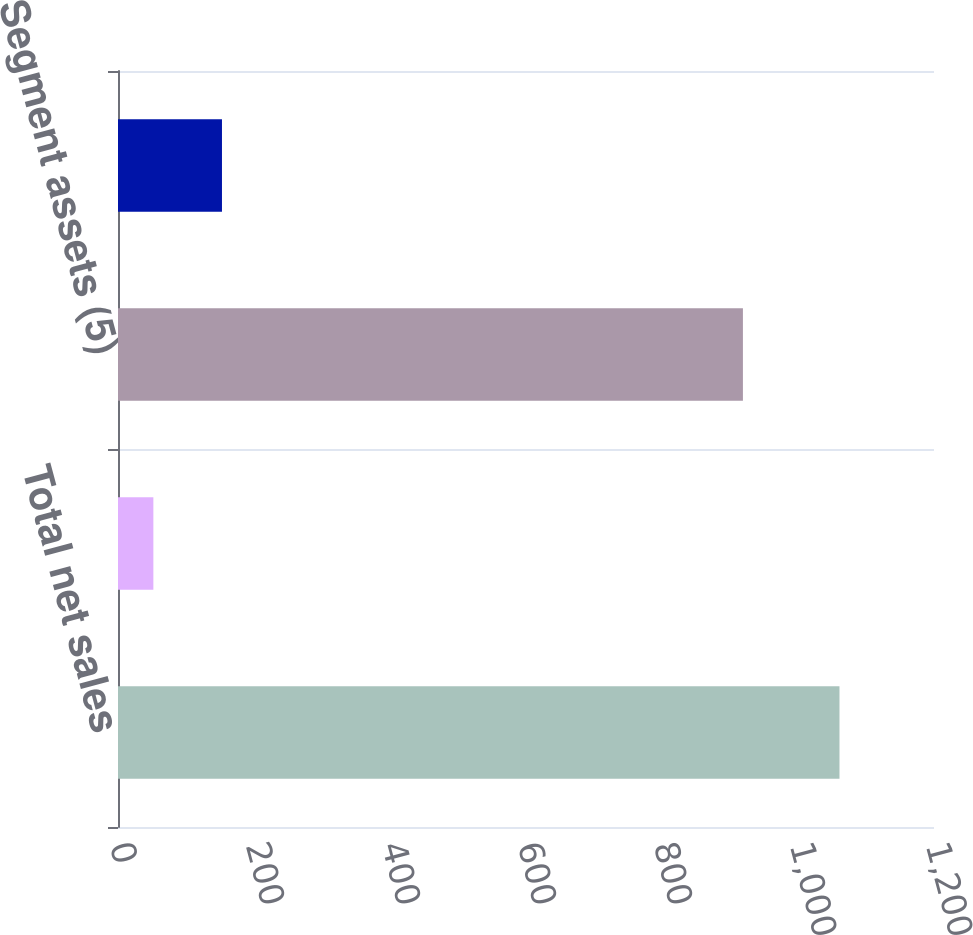Convert chart. <chart><loc_0><loc_0><loc_500><loc_500><bar_chart><fcel>Total net sales<fcel>Depreciation and amortization<fcel>Segment assets (5)<fcel>Expenditures for property<nl><fcel>1061<fcel>52<fcel>919<fcel>152.9<nl></chart> 